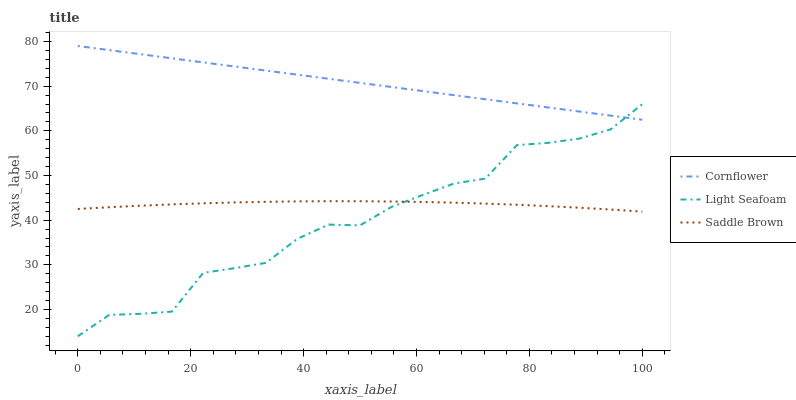Does Light Seafoam have the minimum area under the curve?
Answer yes or no. Yes. Does Cornflower have the maximum area under the curve?
Answer yes or no. Yes. Does Saddle Brown have the minimum area under the curve?
Answer yes or no. No. Does Saddle Brown have the maximum area under the curve?
Answer yes or no. No. Is Cornflower the smoothest?
Answer yes or no. Yes. Is Light Seafoam the roughest?
Answer yes or no. Yes. Is Saddle Brown the smoothest?
Answer yes or no. No. Is Saddle Brown the roughest?
Answer yes or no. No. Does Light Seafoam have the lowest value?
Answer yes or no. Yes. Does Saddle Brown have the lowest value?
Answer yes or no. No. Does Cornflower have the highest value?
Answer yes or no. Yes. Does Light Seafoam have the highest value?
Answer yes or no. No. Is Saddle Brown less than Cornflower?
Answer yes or no. Yes. Is Cornflower greater than Saddle Brown?
Answer yes or no. Yes. Does Cornflower intersect Light Seafoam?
Answer yes or no. Yes. Is Cornflower less than Light Seafoam?
Answer yes or no. No. Is Cornflower greater than Light Seafoam?
Answer yes or no. No. Does Saddle Brown intersect Cornflower?
Answer yes or no. No. 